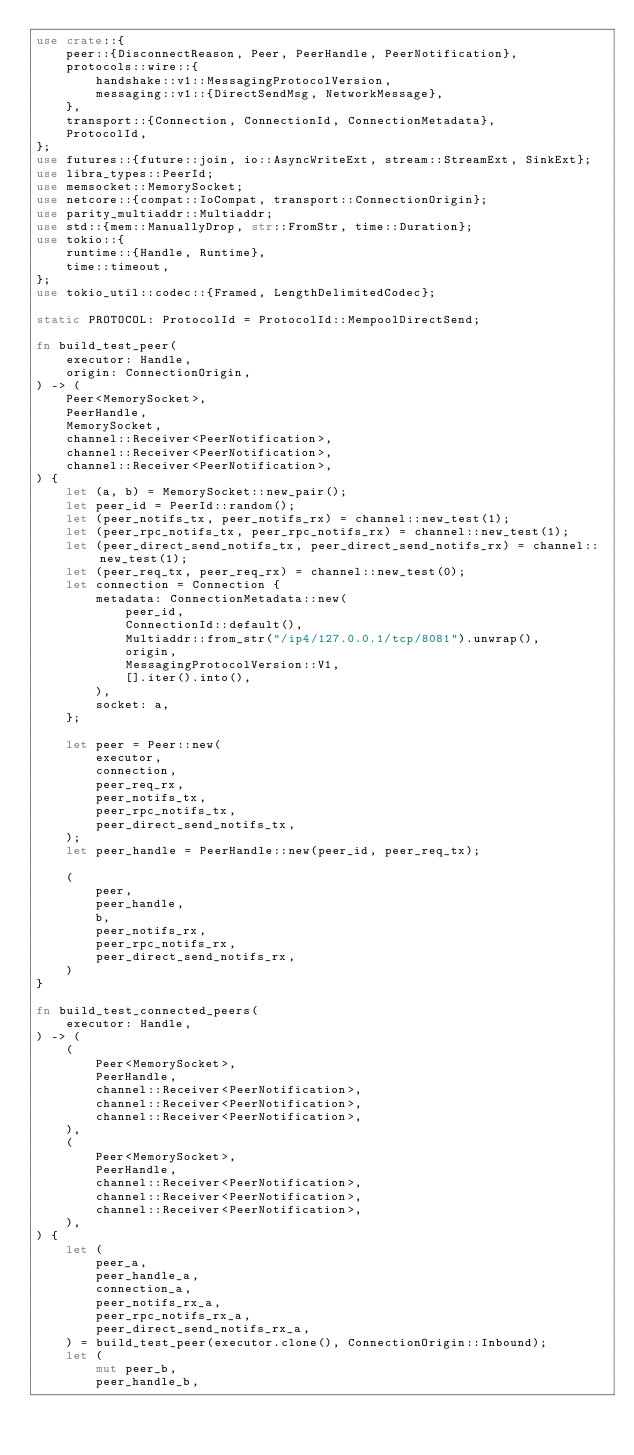Convert code to text. <code><loc_0><loc_0><loc_500><loc_500><_Rust_>use crate::{
    peer::{DisconnectReason, Peer, PeerHandle, PeerNotification},
    protocols::wire::{
        handshake::v1::MessagingProtocolVersion,
        messaging::v1::{DirectSendMsg, NetworkMessage},
    },
    transport::{Connection, ConnectionId, ConnectionMetadata},
    ProtocolId,
};
use futures::{future::join, io::AsyncWriteExt, stream::StreamExt, SinkExt};
use libra_types::PeerId;
use memsocket::MemorySocket;
use netcore::{compat::IoCompat, transport::ConnectionOrigin};
use parity_multiaddr::Multiaddr;
use std::{mem::ManuallyDrop, str::FromStr, time::Duration};
use tokio::{
    runtime::{Handle, Runtime},
    time::timeout,
};
use tokio_util::codec::{Framed, LengthDelimitedCodec};

static PROTOCOL: ProtocolId = ProtocolId::MempoolDirectSend;

fn build_test_peer(
    executor: Handle,
    origin: ConnectionOrigin,
) -> (
    Peer<MemorySocket>,
    PeerHandle,
    MemorySocket,
    channel::Receiver<PeerNotification>,
    channel::Receiver<PeerNotification>,
    channel::Receiver<PeerNotification>,
) {
    let (a, b) = MemorySocket::new_pair();
    let peer_id = PeerId::random();
    let (peer_notifs_tx, peer_notifs_rx) = channel::new_test(1);
    let (peer_rpc_notifs_tx, peer_rpc_notifs_rx) = channel::new_test(1);
    let (peer_direct_send_notifs_tx, peer_direct_send_notifs_rx) = channel::new_test(1);
    let (peer_req_tx, peer_req_rx) = channel::new_test(0);
    let connection = Connection {
        metadata: ConnectionMetadata::new(
            peer_id,
            ConnectionId::default(),
            Multiaddr::from_str("/ip4/127.0.0.1/tcp/8081").unwrap(),
            origin,
            MessagingProtocolVersion::V1,
            [].iter().into(),
        ),
        socket: a,
    };

    let peer = Peer::new(
        executor,
        connection,
        peer_req_rx,
        peer_notifs_tx,
        peer_rpc_notifs_tx,
        peer_direct_send_notifs_tx,
    );
    let peer_handle = PeerHandle::new(peer_id, peer_req_tx);

    (
        peer,
        peer_handle,
        b,
        peer_notifs_rx,
        peer_rpc_notifs_rx,
        peer_direct_send_notifs_rx,
    )
}

fn build_test_connected_peers(
    executor: Handle,
) -> (
    (
        Peer<MemorySocket>,
        PeerHandle,
        channel::Receiver<PeerNotification>,
        channel::Receiver<PeerNotification>,
        channel::Receiver<PeerNotification>,
    ),
    (
        Peer<MemorySocket>,
        PeerHandle,
        channel::Receiver<PeerNotification>,
        channel::Receiver<PeerNotification>,
        channel::Receiver<PeerNotification>,
    ),
) {
    let (
        peer_a,
        peer_handle_a,
        connection_a,
        peer_notifs_rx_a,
        peer_rpc_notifs_rx_a,
        peer_direct_send_notifs_rx_a,
    ) = build_test_peer(executor.clone(), ConnectionOrigin::Inbound);
    let (
        mut peer_b,
        peer_handle_b,</code> 